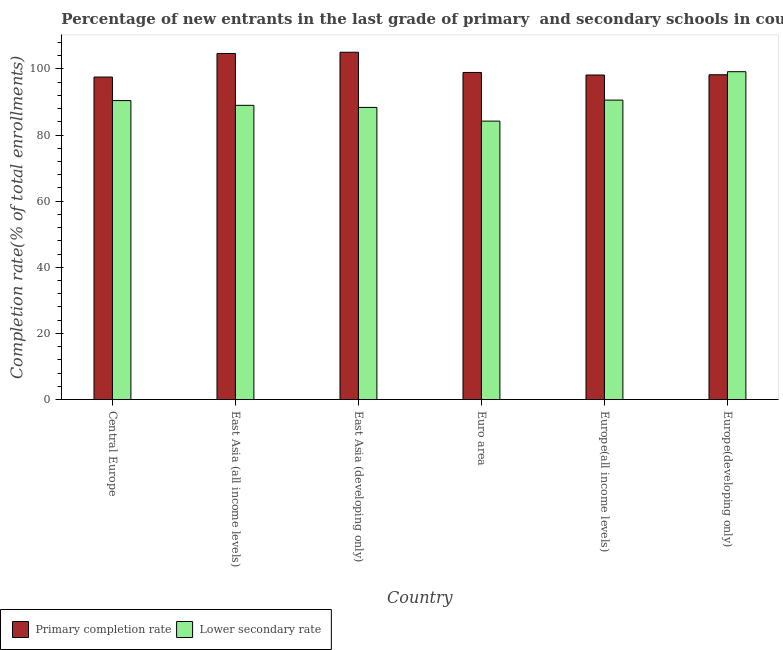How many groups of bars are there?
Offer a terse response. 6. Are the number of bars per tick equal to the number of legend labels?
Provide a succinct answer. Yes. Are the number of bars on each tick of the X-axis equal?
Your answer should be very brief. Yes. What is the label of the 2nd group of bars from the left?
Keep it short and to the point. East Asia (all income levels). In how many cases, is the number of bars for a given country not equal to the number of legend labels?
Your answer should be compact. 0. What is the completion rate in primary schools in East Asia (all income levels)?
Give a very brief answer. 104.67. Across all countries, what is the maximum completion rate in secondary schools?
Offer a very short reply. 99.16. Across all countries, what is the minimum completion rate in primary schools?
Make the answer very short. 97.55. In which country was the completion rate in primary schools maximum?
Your response must be concise. East Asia (developing only). In which country was the completion rate in primary schools minimum?
Make the answer very short. Central Europe. What is the total completion rate in primary schools in the graph?
Provide a short and direct response. 602.6. What is the difference between the completion rate in primary schools in East Asia (all income levels) and that in East Asia (developing only)?
Ensure brevity in your answer.  -0.37. What is the difference between the completion rate in secondary schools in Europe(all income levels) and the completion rate in primary schools in Europe(developing only)?
Your response must be concise. -7.67. What is the average completion rate in primary schools per country?
Ensure brevity in your answer.  100.43. What is the difference between the completion rate in secondary schools and completion rate in primary schools in East Asia (all income levels)?
Provide a succinct answer. -15.69. What is the ratio of the completion rate in primary schools in Europe(all income levels) to that in Europe(developing only)?
Ensure brevity in your answer.  1. Is the difference between the completion rate in secondary schools in Euro area and Europe(all income levels) greater than the difference between the completion rate in primary schools in Euro area and Europe(all income levels)?
Offer a terse response. No. What is the difference between the highest and the second highest completion rate in primary schools?
Your response must be concise. 0.37. What is the difference between the highest and the lowest completion rate in primary schools?
Offer a terse response. 7.5. What does the 2nd bar from the left in Central Europe represents?
Ensure brevity in your answer.  Lower secondary rate. What does the 1st bar from the right in East Asia (developing only) represents?
Your answer should be compact. Lower secondary rate. Are all the bars in the graph horizontal?
Your answer should be compact. No. What is the difference between two consecutive major ticks on the Y-axis?
Keep it short and to the point. 20. Are the values on the major ticks of Y-axis written in scientific E-notation?
Make the answer very short. No. Does the graph contain any zero values?
Your response must be concise. No. Does the graph contain grids?
Offer a very short reply. No. What is the title of the graph?
Your answer should be compact. Percentage of new entrants in the last grade of primary  and secondary schools in countries. Does "Goods and services" appear as one of the legend labels in the graph?
Make the answer very short. No. What is the label or title of the Y-axis?
Keep it short and to the point. Completion rate(% of total enrollments). What is the Completion rate(% of total enrollments) in Primary completion rate in Central Europe?
Give a very brief answer. 97.55. What is the Completion rate(% of total enrollments) in Lower secondary rate in Central Europe?
Give a very brief answer. 90.43. What is the Completion rate(% of total enrollments) of Primary completion rate in East Asia (all income levels)?
Give a very brief answer. 104.67. What is the Completion rate(% of total enrollments) of Lower secondary rate in East Asia (all income levels)?
Make the answer very short. 88.99. What is the Completion rate(% of total enrollments) in Primary completion rate in East Asia (developing only)?
Provide a succinct answer. 105.05. What is the Completion rate(% of total enrollments) in Lower secondary rate in East Asia (developing only)?
Your answer should be compact. 88.36. What is the Completion rate(% of total enrollments) of Primary completion rate in Euro area?
Offer a terse response. 98.93. What is the Completion rate(% of total enrollments) of Lower secondary rate in Euro area?
Ensure brevity in your answer.  84.21. What is the Completion rate(% of total enrollments) of Primary completion rate in Europe(all income levels)?
Provide a short and direct response. 98.16. What is the Completion rate(% of total enrollments) in Lower secondary rate in Europe(all income levels)?
Provide a succinct answer. 90.57. What is the Completion rate(% of total enrollments) of Primary completion rate in Europe(developing only)?
Give a very brief answer. 98.24. What is the Completion rate(% of total enrollments) of Lower secondary rate in Europe(developing only)?
Ensure brevity in your answer.  99.16. Across all countries, what is the maximum Completion rate(% of total enrollments) in Primary completion rate?
Your answer should be compact. 105.05. Across all countries, what is the maximum Completion rate(% of total enrollments) of Lower secondary rate?
Ensure brevity in your answer.  99.16. Across all countries, what is the minimum Completion rate(% of total enrollments) in Primary completion rate?
Make the answer very short. 97.55. Across all countries, what is the minimum Completion rate(% of total enrollments) of Lower secondary rate?
Your response must be concise. 84.21. What is the total Completion rate(% of total enrollments) of Primary completion rate in the graph?
Keep it short and to the point. 602.6. What is the total Completion rate(% of total enrollments) of Lower secondary rate in the graph?
Provide a short and direct response. 541.71. What is the difference between the Completion rate(% of total enrollments) in Primary completion rate in Central Europe and that in East Asia (all income levels)?
Provide a short and direct response. -7.13. What is the difference between the Completion rate(% of total enrollments) of Lower secondary rate in Central Europe and that in East Asia (all income levels)?
Give a very brief answer. 1.44. What is the difference between the Completion rate(% of total enrollments) of Primary completion rate in Central Europe and that in East Asia (developing only)?
Provide a short and direct response. -7.5. What is the difference between the Completion rate(% of total enrollments) in Lower secondary rate in Central Europe and that in East Asia (developing only)?
Provide a short and direct response. 2.07. What is the difference between the Completion rate(% of total enrollments) in Primary completion rate in Central Europe and that in Euro area?
Ensure brevity in your answer.  -1.38. What is the difference between the Completion rate(% of total enrollments) of Lower secondary rate in Central Europe and that in Euro area?
Give a very brief answer. 6.21. What is the difference between the Completion rate(% of total enrollments) in Primary completion rate in Central Europe and that in Europe(all income levels)?
Ensure brevity in your answer.  -0.62. What is the difference between the Completion rate(% of total enrollments) of Lower secondary rate in Central Europe and that in Europe(all income levels)?
Give a very brief answer. -0.14. What is the difference between the Completion rate(% of total enrollments) in Primary completion rate in Central Europe and that in Europe(developing only)?
Your answer should be very brief. -0.69. What is the difference between the Completion rate(% of total enrollments) in Lower secondary rate in Central Europe and that in Europe(developing only)?
Give a very brief answer. -8.74. What is the difference between the Completion rate(% of total enrollments) of Primary completion rate in East Asia (all income levels) and that in East Asia (developing only)?
Make the answer very short. -0.37. What is the difference between the Completion rate(% of total enrollments) in Lower secondary rate in East Asia (all income levels) and that in East Asia (developing only)?
Keep it short and to the point. 0.63. What is the difference between the Completion rate(% of total enrollments) in Primary completion rate in East Asia (all income levels) and that in Euro area?
Offer a very short reply. 5.74. What is the difference between the Completion rate(% of total enrollments) of Lower secondary rate in East Asia (all income levels) and that in Euro area?
Your answer should be very brief. 4.77. What is the difference between the Completion rate(% of total enrollments) in Primary completion rate in East Asia (all income levels) and that in Europe(all income levels)?
Offer a terse response. 6.51. What is the difference between the Completion rate(% of total enrollments) in Lower secondary rate in East Asia (all income levels) and that in Europe(all income levels)?
Your answer should be very brief. -1.58. What is the difference between the Completion rate(% of total enrollments) in Primary completion rate in East Asia (all income levels) and that in Europe(developing only)?
Offer a terse response. 6.44. What is the difference between the Completion rate(% of total enrollments) in Lower secondary rate in East Asia (all income levels) and that in Europe(developing only)?
Keep it short and to the point. -10.18. What is the difference between the Completion rate(% of total enrollments) of Primary completion rate in East Asia (developing only) and that in Euro area?
Provide a short and direct response. 6.12. What is the difference between the Completion rate(% of total enrollments) in Lower secondary rate in East Asia (developing only) and that in Euro area?
Provide a succinct answer. 4.15. What is the difference between the Completion rate(% of total enrollments) of Primary completion rate in East Asia (developing only) and that in Europe(all income levels)?
Provide a succinct answer. 6.89. What is the difference between the Completion rate(% of total enrollments) in Lower secondary rate in East Asia (developing only) and that in Europe(all income levels)?
Your answer should be very brief. -2.21. What is the difference between the Completion rate(% of total enrollments) of Primary completion rate in East Asia (developing only) and that in Europe(developing only)?
Offer a very short reply. 6.81. What is the difference between the Completion rate(% of total enrollments) of Lower secondary rate in East Asia (developing only) and that in Europe(developing only)?
Offer a very short reply. -10.8. What is the difference between the Completion rate(% of total enrollments) of Primary completion rate in Euro area and that in Europe(all income levels)?
Give a very brief answer. 0.77. What is the difference between the Completion rate(% of total enrollments) of Lower secondary rate in Euro area and that in Europe(all income levels)?
Keep it short and to the point. -6.36. What is the difference between the Completion rate(% of total enrollments) of Primary completion rate in Euro area and that in Europe(developing only)?
Provide a short and direct response. 0.7. What is the difference between the Completion rate(% of total enrollments) in Lower secondary rate in Euro area and that in Europe(developing only)?
Ensure brevity in your answer.  -14.95. What is the difference between the Completion rate(% of total enrollments) of Primary completion rate in Europe(all income levels) and that in Europe(developing only)?
Offer a terse response. -0.07. What is the difference between the Completion rate(% of total enrollments) in Lower secondary rate in Europe(all income levels) and that in Europe(developing only)?
Give a very brief answer. -8.59. What is the difference between the Completion rate(% of total enrollments) in Primary completion rate in Central Europe and the Completion rate(% of total enrollments) in Lower secondary rate in East Asia (all income levels)?
Give a very brief answer. 8.56. What is the difference between the Completion rate(% of total enrollments) of Primary completion rate in Central Europe and the Completion rate(% of total enrollments) of Lower secondary rate in East Asia (developing only)?
Your answer should be very brief. 9.19. What is the difference between the Completion rate(% of total enrollments) of Primary completion rate in Central Europe and the Completion rate(% of total enrollments) of Lower secondary rate in Euro area?
Offer a terse response. 13.33. What is the difference between the Completion rate(% of total enrollments) in Primary completion rate in Central Europe and the Completion rate(% of total enrollments) in Lower secondary rate in Europe(all income levels)?
Your answer should be very brief. 6.98. What is the difference between the Completion rate(% of total enrollments) of Primary completion rate in Central Europe and the Completion rate(% of total enrollments) of Lower secondary rate in Europe(developing only)?
Provide a succinct answer. -1.62. What is the difference between the Completion rate(% of total enrollments) of Primary completion rate in East Asia (all income levels) and the Completion rate(% of total enrollments) of Lower secondary rate in East Asia (developing only)?
Keep it short and to the point. 16.32. What is the difference between the Completion rate(% of total enrollments) in Primary completion rate in East Asia (all income levels) and the Completion rate(% of total enrollments) in Lower secondary rate in Euro area?
Provide a short and direct response. 20.46. What is the difference between the Completion rate(% of total enrollments) of Primary completion rate in East Asia (all income levels) and the Completion rate(% of total enrollments) of Lower secondary rate in Europe(all income levels)?
Give a very brief answer. 14.11. What is the difference between the Completion rate(% of total enrollments) in Primary completion rate in East Asia (all income levels) and the Completion rate(% of total enrollments) in Lower secondary rate in Europe(developing only)?
Your answer should be compact. 5.51. What is the difference between the Completion rate(% of total enrollments) in Primary completion rate in East Asia (developing only) and the Completion rate(% of total enrollments) in Lower secondary rate in Euro area?
Your answer should be very brief. 20.84. What is the difference between the Completion rate(% of total enrollments) of Primary completion rate in East Asia (developing only) and the Completion rate(% of total enrollments) of Lower secondary rate in Europe(all income levels)?
Keep it short and to the point. 14.48. What is the difference between the Completion rate(% of total enrollments) in Primary completion rate in East Asia (developing only) and the Completion rate(% of total enrollments) in Lower secondary rate in Europe(developing only)?
Provide a succinct answer. 5.88. What is the difference between the Completion rate(% of total enrollments) of Primary completion rate in Euro area and the Completion rate(% of total enrollments) of Lower secondary rate in Europe(all income levels)?
Provide a succinct answer. 8.36. What is the difference between the Completion rate(% of total enrollments) in Primary completion rate in Euro area and the Completion rate(% of total enrollments) in Lower secondary rate in Europe(developing only)?
Offer a terse response. -0.23. What is the difference between the Completion rate(% of total enrollments) in Primary completion rate in Europe(all income levels) and the Completion rate(% of total enrollments) in Lower secondary rate in Europe(developing only)?
Your response must be concise. -1. What is the average Completion rate(% of total enrollments) of Primary completion rate per country?
Make the answer very short. 100.43. What is the average Completion rate(% of total enrollments) in Lower secondary rate per country?
Give a very brief answer. 90.29. What is the difference between the Completion rate(% of total enrollments) in Primary completion rate and Completion rate(% of total enrollments) in Lower secondary rate in Central Europe?
Keep it short and to the point. 7.12. What is the difference between the Completion rate(% of total enrollments) in Primary completion rate and Completion rate(% of total enrollments) in Lower secondary rate in East Asia (all income levels)?
Give a very brief answer. 15.69. What is the difference between the Completion rate(% of total enrollments) of Primary completion rate and Completion rate(% of total enrollments) of Lower secondary rate in East Asia (developing only)?
Your answer should be very brief. 16.69. What is the difference between the Completion rate(% of total enrollments) in Primary completion rate and Completion rate(% of total enrollments) in Lower secondary rate in Euro area?
Keep it short and to the point. 14.72. What is the difference between the Completion rate(% of total enrollments) of Primary completion rate and Completion rate(% of total enrollments) of Lower secondary rate in Europe(all income levels)?
Keep it short and to the point. 7.59. What is the difference between the Completion rate(% of total enrollments) in Primary completion rate and Completion rate(% of total enrollments) in Lower secondary rate in Europe(developing only)?
Your answer should be compact. -0.93. What is the ratio of the Completion rate(% of total enrollments) of Primary completion rate in Central Europe to that in East Asia (all income levels)?
Your answer should be compact. 0.93. What is the ratio of the Completion rate(% of total enrollments) in Lower secondary rate in Central Europe to that in East Asia (all income levels)?
Ensure brevity in your answer.  1.02. What is the ratio of the Completion rate(% of total enrollments) of Lower secondary rate in Central Europe to that in East Asia (developing only)?
Give a very brief answer. 1.02. What is the ratio of the Completion rate(% of total enrollments) of Primary completion rate in Central Europe to that in Euro area?
Offer a very short reply. 0.99. What is the ratio of the Completion rate(% of total enrollments) of Lower secondary rate in Central Europe to that in Euro area?
Your response must be concise. 1.07. What is the ratio of the Completion rate(% of total enrollments) of Lower secondary rate in Central Europe to that in Europe(all income levels)?
Keep it short and to the point. 1. What is the ratio of the Completion rate(% of total enrollments) in Primary completion rate in Central Europe to that in Europe(developing only)?
Offer a very short reply. 0.99. What is the ratio of the Completion rate(% of total enrollments) of Lower secondary rate in Central Europe to that in Europe(developing only)?
Give a very brief answer. 0.91. What is the ratio of the Completion rate(% of total enrollments) in Lower secondary rate in East Asia (all income levels) to that in East Asia (developing only)?
Your response must be concise. 1.01. What is the ratio of the Completion rate(% of total enrollments) of Primary completion rate in East Asia (all income levels) to that in Euro area?
Your answer should be compact. 1.06. What is the ratio of the Completion rate(% of total enrollments) in Lower secondary rate in East Asia (all income levels) to that in Euro area?
Provide a succinct answer. 1.06. What is the ratio of the Completion rate(% of total enrollments) in Primary completion rate in East Asia (all income levels) to that in Europe(all income levels)?
Keep it short and to the point. 1.07. What is the ratio of the Completion rate(% of total enrollments) of Lower secondary rate in East Asia (all income levels) to that in Europe(all income levels)?
Offer a terse response. 0.98. What is the ratio of the Completion rate(% of total enrollments) of Primary completion rate in East Asia (all income levels) to that in Europe(developing only)?
Make the answer very short. 1.07. What is the ratio of the Completion rate(% of total enrollments) of Lower secondary rate in East Asia (all income levels) to that in Europe(developing only)?
Your answer should be very brief. 0.9. What is the ratio of the Completion rate(% of total enrollments) in Primary completion rate in East Asia (developing only) to that in Euro area?
Ensure brevity in your answer.  1.06. What is the ratio of the Completion rate(% of total enrollments) in Lower secondary rate in East Asia (developing only) to that in Euro area?
Make the answer very short. 1.05. What is the ratio of the Completion rate(% of total enrollments) of Primary completion rate in East Asia (developing only) to that in Europe(all income levels)?
Your answer should be compact. 1.07. What is the ratio of the Completion rate(% of total enrollments) in Lower secondary rate in East Asia (developing only) to that in Europe(all income levels)?
Give a very brief answer. 0.98. What is the ratio of the Completion rate(% of total enrollments) in Primary completion rate in East Asia (developing only) to that in Europe(developing only)?
Provide a succinct answer. 1.07. What is the ratio of the Completion rate(% of total enrollments) of Lower secondary rate in East Asia (developing only) to that in Europe(developing only)?
Ensure brevity in your answer.  0.89. What is the ratio of the Completion rate(% of total enrollments) of Lower secondary rate in Euro area to that in Europe(all income levels)?
Offer a very short reply. 0.93. What is the ratio of the Completion rate(% of total enrollments) in Primary completion rate in Euro area to that in Europe(developing only)?
Make the answer very short. 1.01. What is the ratio of the Completion rate(% of total enrollments) in Lower secondary rate in Euro area to that in Europe(developing only)?
Ensure brevity in your answer.  0.85. What is the ratio of the Completion rate(% of total enrollments) of Primary completion rate in Europe(all income levels) to that in Europe(developing only)?
Give a very brief answer. 1. What is the ratio of the Completion rate(% of total enrollments) of Lower secondary rate in Europe(all income levels) to that in Europe(developing only)?
Keep it short and to the point. 0.91. What is the difference between the highest and the second highest Completion rate(% of total enrollments) in Primary completion rate?
Your response must be concise. 0.37. What is the difference between the highest and the second highest Completion rate(% of total enrollments) in Lower secondary rate?
Provide a succinct answer. 8.59. What is the difference between the highest and the lowest Completion rate(% of total enrollments) of Primary completion rate?
Offer a terse response. 7.5. What is the difference between the highest and the lowest Completion rate(% of total enrollments) in Lower secondary rate?
Give a very brief answer. 14.95. 